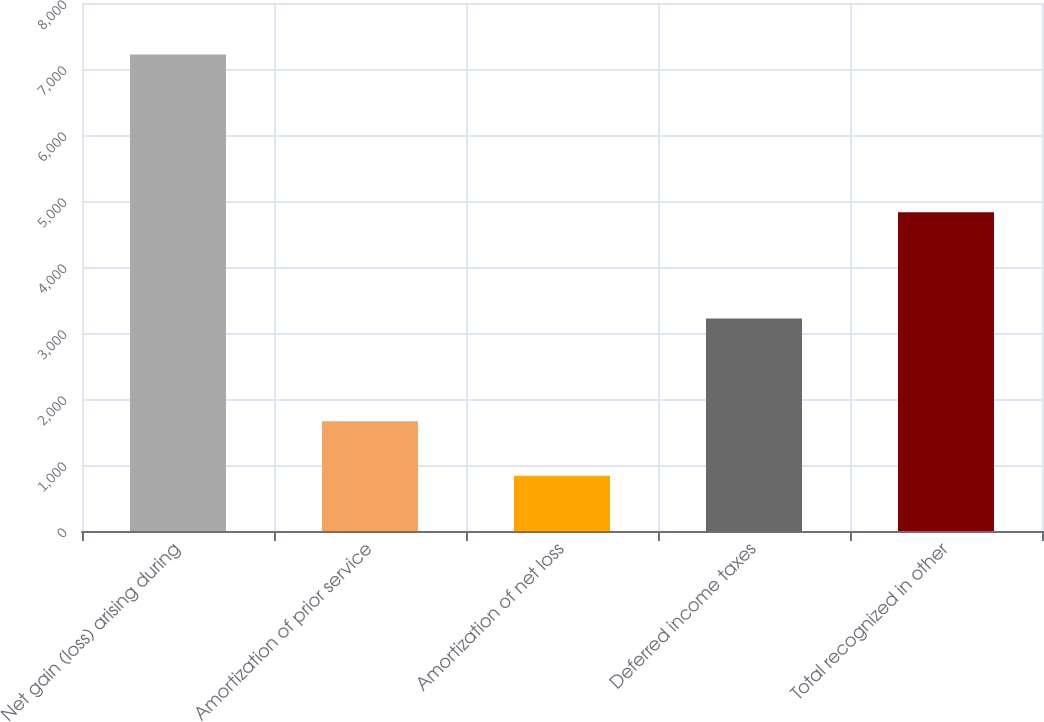<chart> <loc_0><loc_0><loc_500><loc_500><bar_chart><fcel>Net gain (loss) arising during<fcel>Amortization of prior service<fcel>Amortization of net loss<fcel>Deferred income taxes<fcel>Total recognized in other<nl><fcel>7220<fcel>1662<fcel>836<fcel>3218<fcel>4828<nl></chart> 